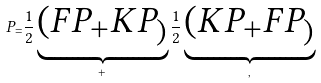<formula> <loc_0><loc_0><loc_500><loc_500>P _ { = } \frac { 1 } { 2 } \underbrace { ( F P _ { + } K P _ { ) } } _ { + } \frac { 1 } { 2 } \underbrace { ( K P _ { + } F P _ { ) } } _ { , }</formula> 